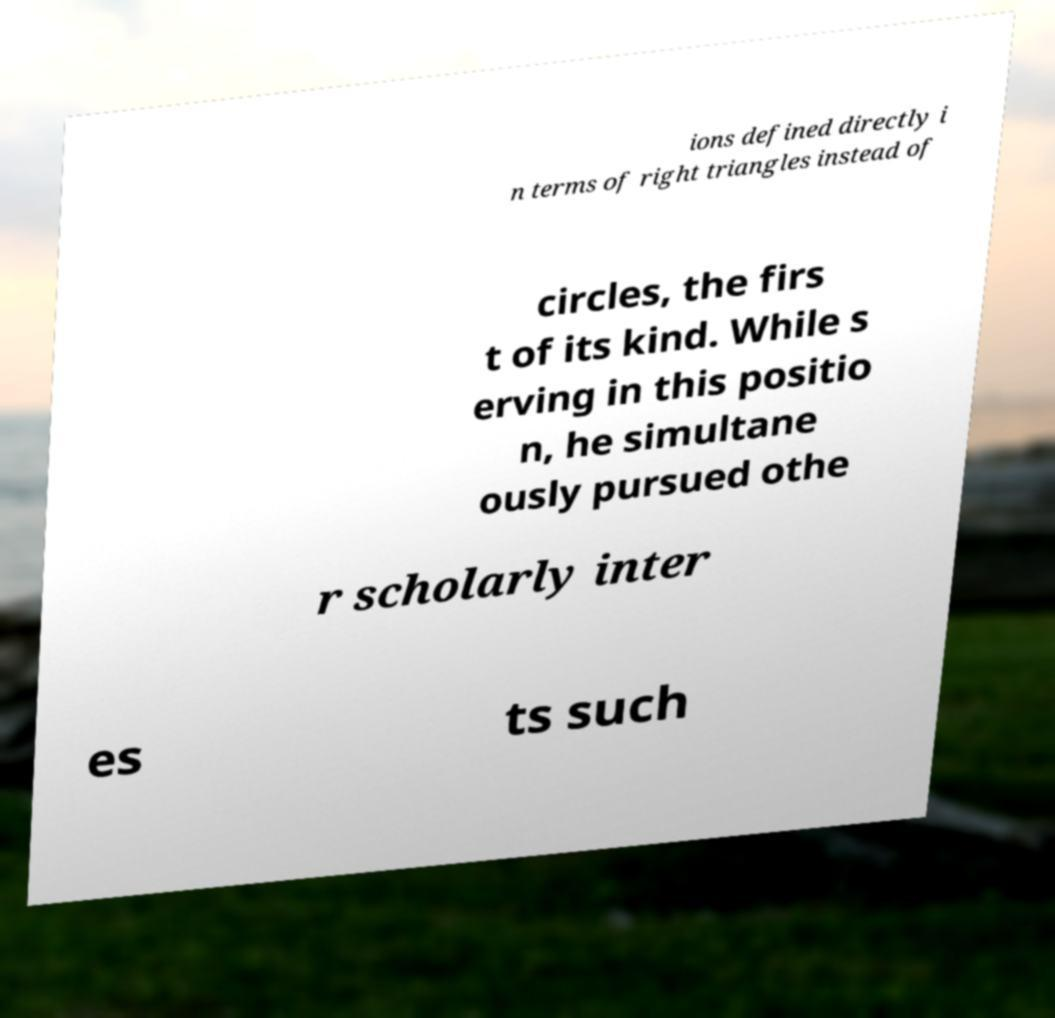Can you read and provide the text displayed in the image?This photo seems to have some interesting text. Can you extract and type it out for me? ions defined directly i n terms of right triangles instead of circles, the firs t of its kind. While s erving in this positio n, he simultane ously pursued othe r scholarly inter es ts such 